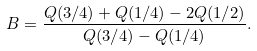Convert formula to latex. <formula><loc_0><loc_0><loc_500><loc_500>B = \frac { Q ( 3 / 4 ) + Q ( 1 / 4 ) - 2 Q ( 1 / 2 ) } { Q ( 3 / 4 ) - Q ( 1 / 4 ) } .</formula> 